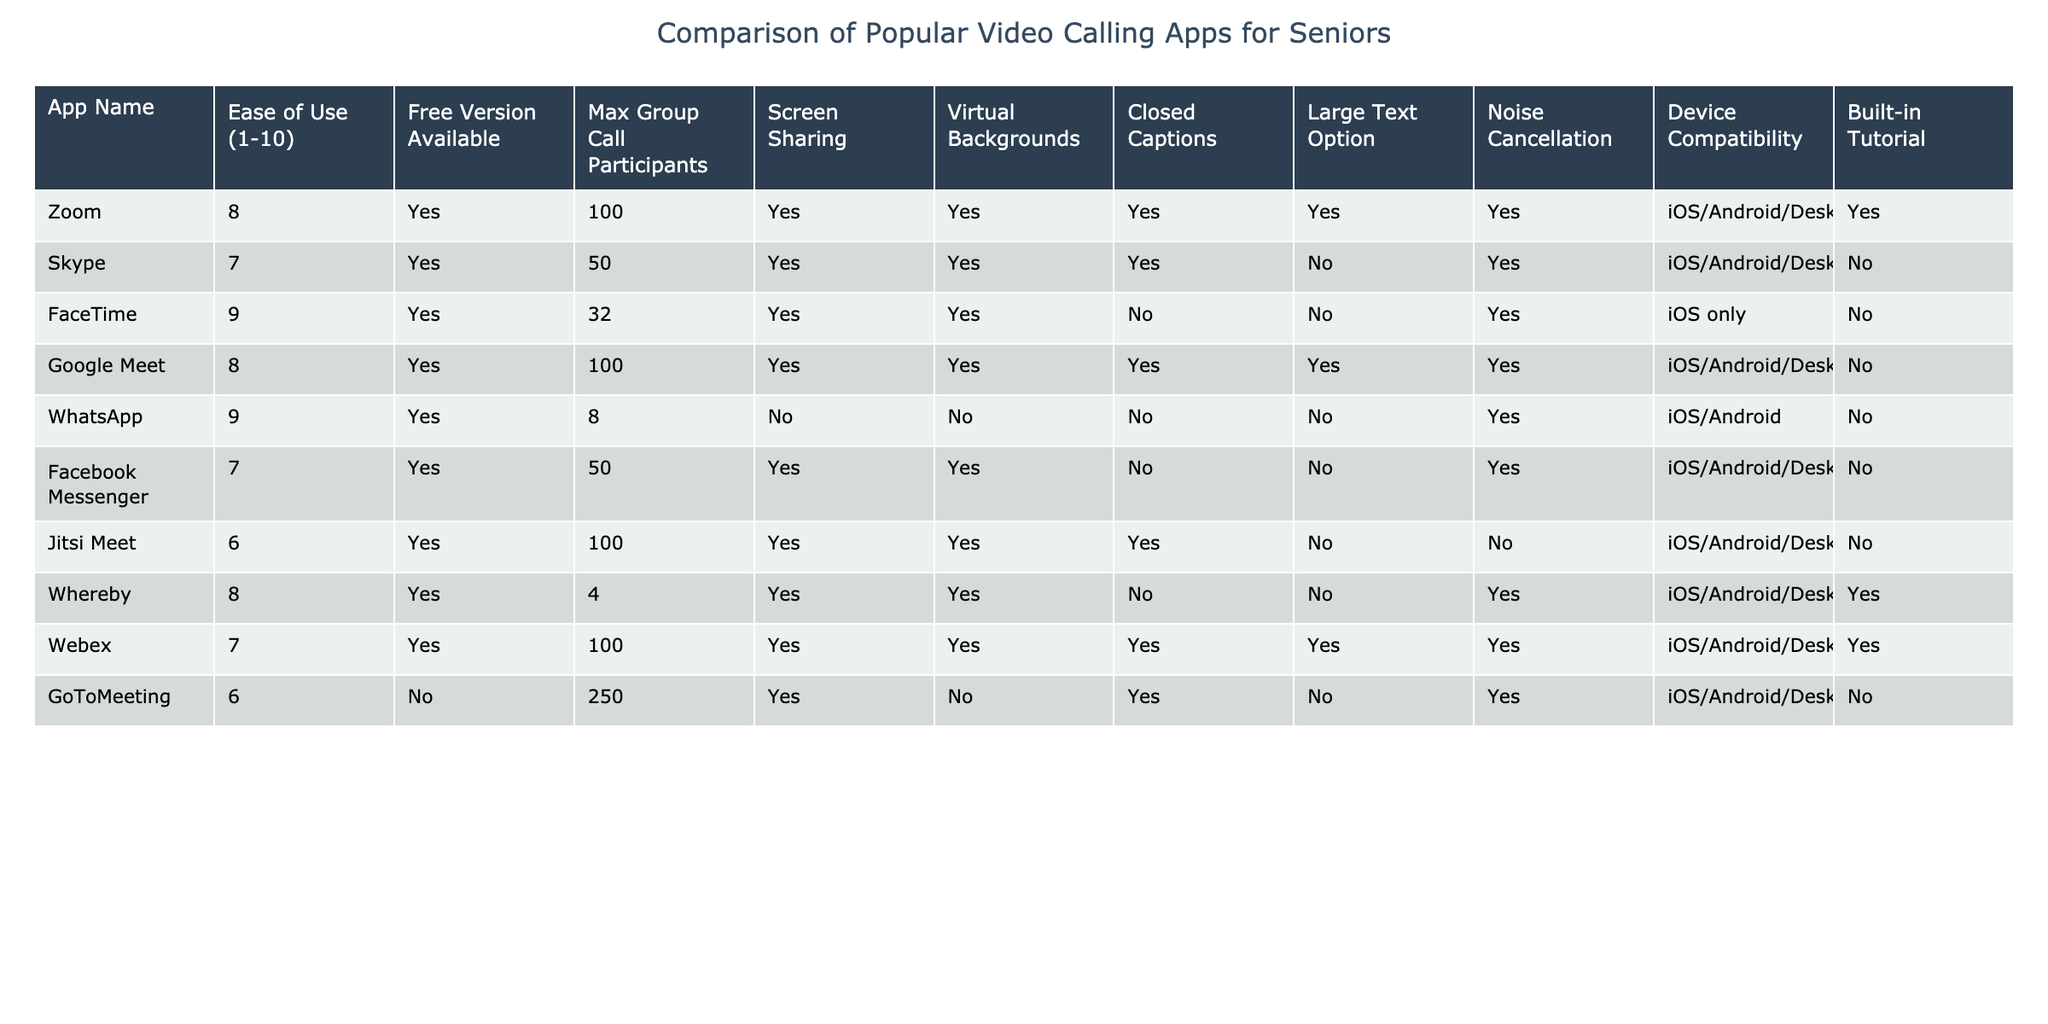What's the maximum number of group call participants in WhatsApp? The table shows that WhatsApp allows a maximum of 8 group call participants, as listed under the "Max Group Call Participants" column.
Answer: 8 Which app has the highest ease of use rating? According to the table, FaceTime has the highest ease of use rating of 9, as indicated in the "Ease of Use" column.
Answer: FaceTime Does Skype offer noise cancellation? By looking at the table, we can see that Skype does provide noise cancellation, which is marked as "Yes" in the "Noise Cancellation" column.
Answer: Yes How many apps have closed captions available? In the table, there are 5 apps that offer closed captions: Zoom, Skype, Google Meet, Webex, and Jitsi Meet. Counting these entries gives us a total of 5 apps.
Answer: 5 Which app has the largest number of maximum group call participants? Looking through the "Max Group Call Participants" column, GoToMeeting has the largest number at 250, more than any other app listed.
Answer: 250 Is there a built-in tutorial available for FaceTime? The table shows that FaceTime does not have a built-in tutorial, as indicated by "No" in the "Built-in Tutorial" column.
Answer: No How many apps are compatible with iOS and Android devices? By reviewing the "Device Compatibility" column, we find that 6 apps (Zoom, Google Meet, WhatsApp, Facebook Messenger, Jitsi Meet, and Whereby) are compatible with both iOS and Android devices.
Answer: 6 Which two apps offer virtual backgrounds and have noise cancellation? Checking both the "Virtual Backgrounds" and "Noise Cancellation" columns, Zoom and Webex are the only apps that have both features available.
Answer: Zoom, Webex What is the average ease of use rating of all the apps? The ease of use ratings are: 8, 7, 9, 8, 9, 7, 6, 8, 7, and 6. Summing these values gives 79, and dividing by the number of apps (10), the average is 7.9.
Answer: 7.9 Which app has the lowest ease of use rating and what features does it lack? Jitsi Meet has the lowest ease of use rating of 6. It lacks large text option and noise cancellation, as indicated in the table, marked "No" in those columns.
Answer: Jitsi Meet; lacks large text option, noise cancellation 